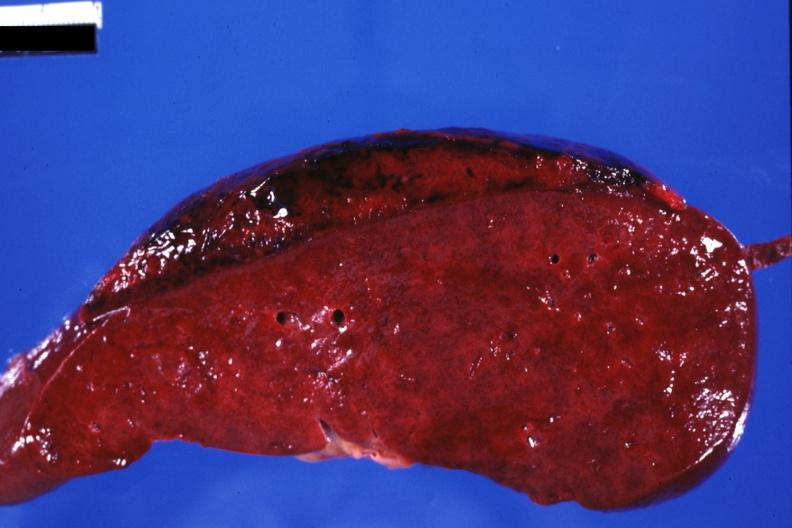s hematologic present?
Answer the question using a single word or phrase. Yes 